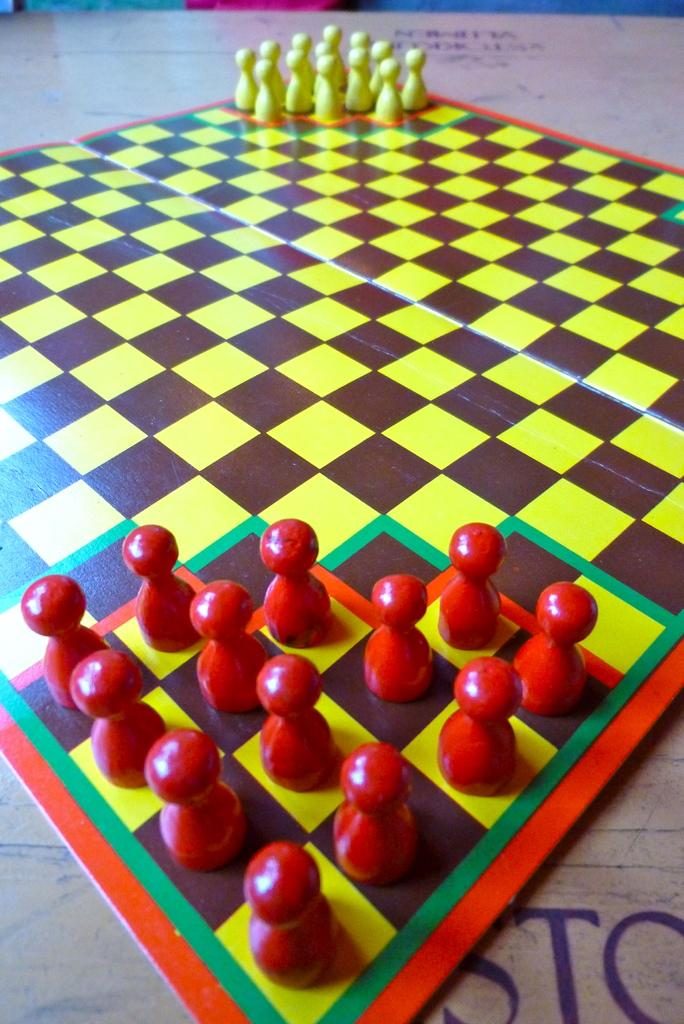What is the main subject of the image? The main subject of the image is a chess board. What can you tell me about the colors of the chess pieces? The chess pieces are red and yellow in color. What type of lipstick is the doll wearing in the image? There is no doll present in the image, and therefore no doll wearing lipstick can be observed. 